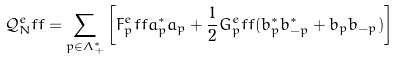<formula> <loc_0><loc_0><loc_500><loc_500>\mathcal { Q } _ { N } ^ { e } f f = \sum _ { p \in \Lambda _ { + } ^ { * } } \left [ F _ { p } ^ { e } f f a ^ { * } _ { p } a _ { p } + \frac { 1 } { 2 } G _ { p } ^ { e } f f ( b ^ { * } _ { p } b ^ { * } _ { - p } + b _ { p } b _ { - p } ) \right ]</formula> 